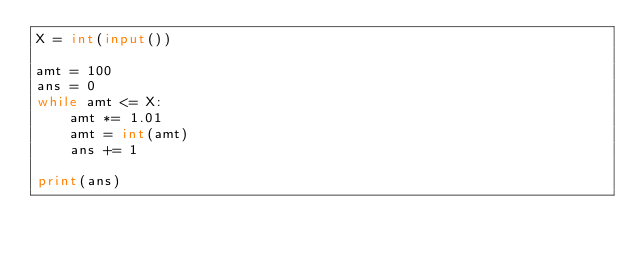<code> <loc_0><loc_0><loc_500><loc_500><_Python_>X = int(input())

amt = 100
ans = 0
while amt <= X:
    amt *= 1.01
    amt = int(amt)
    ans += 1

print(ans)
</code> 